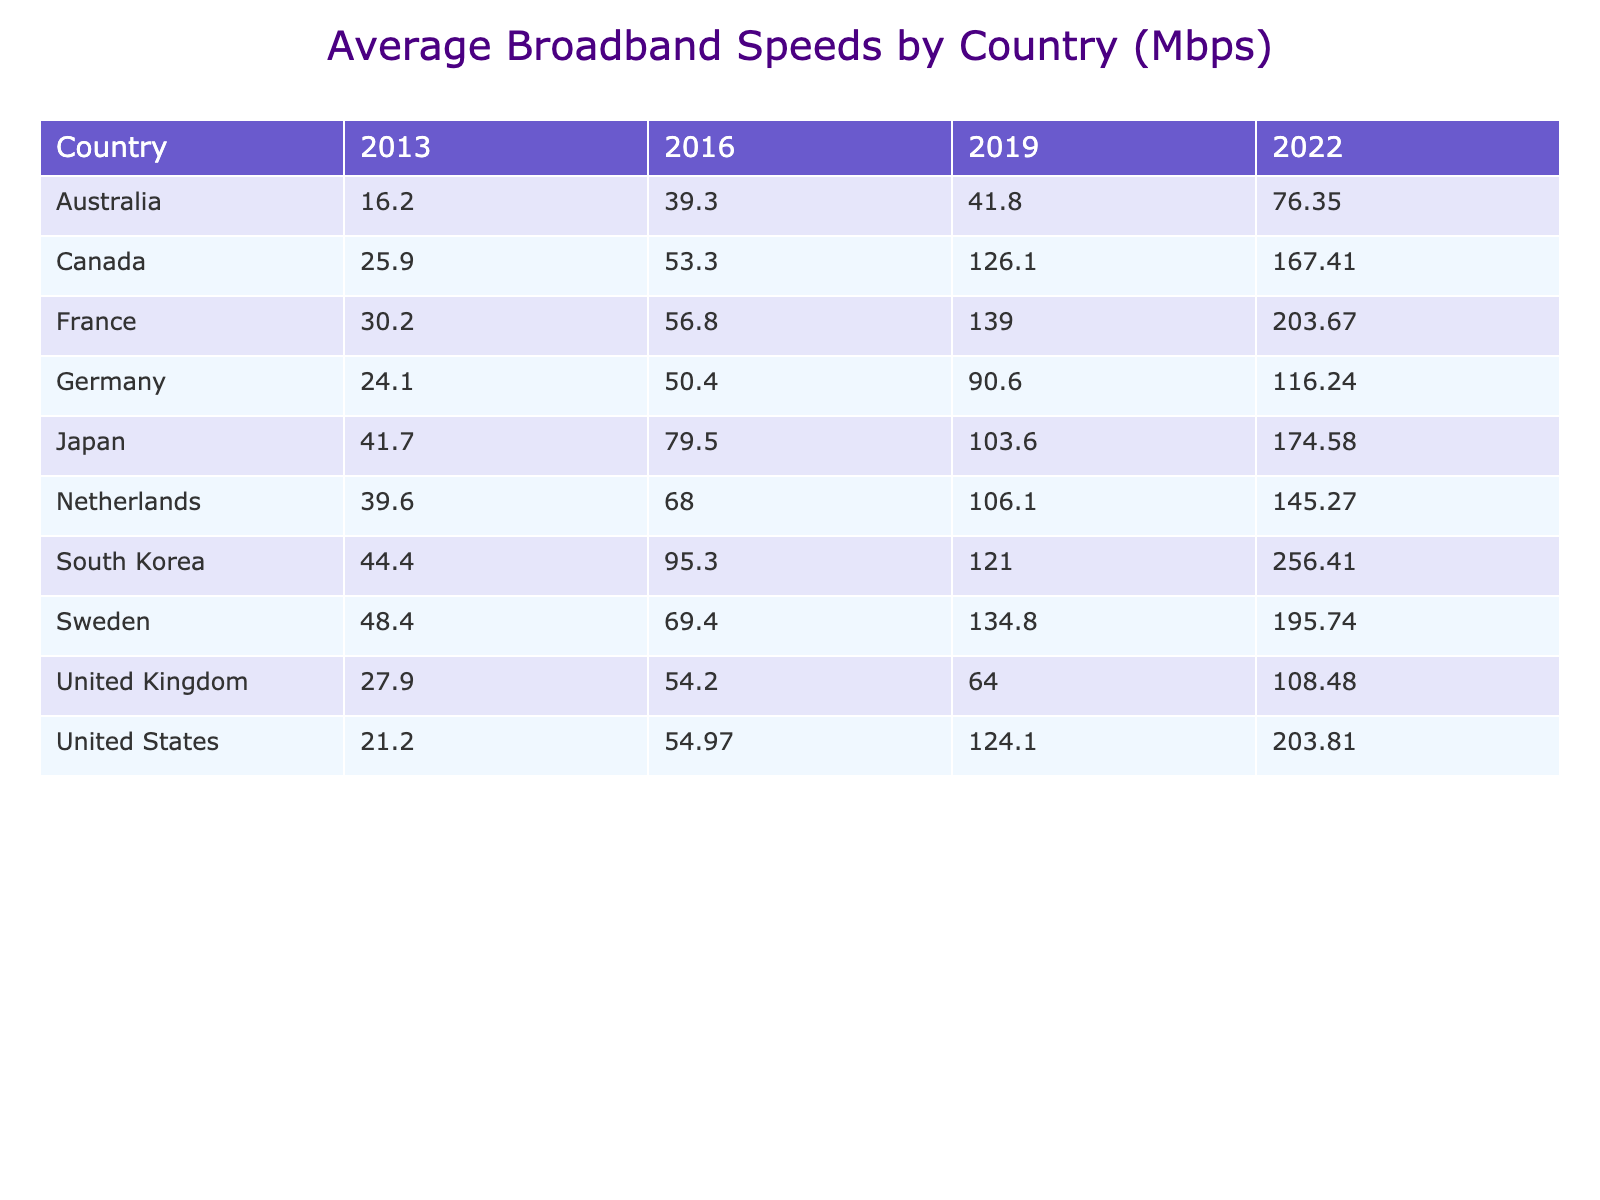What was the average broadband speed in the United States in 2022? The table shows that for the year 2022, the average broadband speed in the United States was 203.81 Mbps.
Answer: 203.81 Mbps Which country had the highest average broadband speed in 2019? According to the table, South Korea had the highest average broadband speed in 2019, which was 121.0 Mbps.
Answer: South Korea What was the change in average broadband speed for Canada from 2016 to 2022? The average broadband speed in Canada increased from 53.3 Mbps in 2016 to 167.41 Mbps in 2022. The difference is 167.41 - 53.3 = 114.11 Mbps.
Answer: 114.11 Mbps In which year did Japan see its average broadband speed exceed 100 Mbps for the first time? Japan's average broadband speed exceeded 100 Mbps in the year 2019, where it reached 103.6 Mbps, as shown in the table.
Answer: 2019 What is the average broadband speed across all countries for the year 2022? To find the average speed for 2022, we add the speeds for each country: (203.81 + 256.41 + 174.58 + 195.74 + 145.27 + 116.24 + 203.67 + 108.48 + 167.41 + 76.35) = 1,514.05 Mbps. There are 10 countries, so the average is 1,514.05/10 = 151.41 Mbps.
Answer: 151.41 Mbps Which country had the lowest average broadband speed in 2013? In 2013, Australia had the lowest average broadband speed at 16.2 Mbps, according to the table.
Answer: Australia Was the average broadband speed in Germany in 2022 higher than that of the United Kingdom in the same year? The average broadband speed in Germany for 2022 was 116.24 Mbps, while in the United Kingdom, it was 108.48 Mbps. Thus, Germany's speed was higher.
Answer: Yes How many countries had an average broadband speed of over 200 Mbps in 2022? By checking the table, we find that South Korea and the United States both had average broadband speeds above 200 Mbps in 2022 (256.41 Mbps and 203.81 Mbps respectively). Therefore, there are 2 countries.
Answer: 2 What was the percentage increase in average broadband speed for Sweden from 2013 to 2022? Sweden's average broadband speed increased from 48.4 Mbps in 2013 to 195.74 Mbps in 2022. The increase is 195.74 - 48.4 = 147.34 Mbps. The percentage increase is (147.34/48.4) * 100 = 304.28%.
Answer: 304.28% Which two countries had the closest average broadband speeds in 2016? In 2016, the average broadband speeds for the Netherlands (68.0 Mbps) and Germany (50.4 Mbps) were compared, and France (56.8 Mbps) falls in between them, but the closest speeds are between Germany and France.
Answer: Germany and France What was the average broadband speed for the Netherlands over the entire decade? To find the average, we sum the speeds for the Netherlands across the years: (39.6 + 68.0 + 106.1 + 145.27) = 359.97 Mbps. Then, average it by dividing by 4: 359.97 / 4 = 89.9925 Mbps.
Answer: 89.99 Mbps 